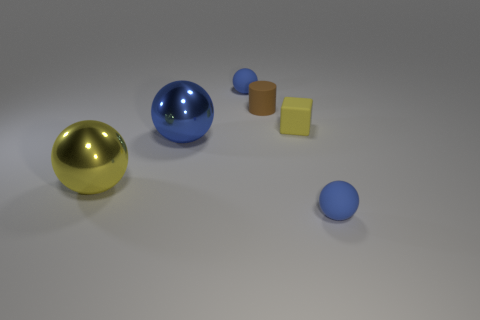Subtract all large yellow spheres. How many spheres are left? 3 Subtract all green cylinders. How many blue balls are left? 3 Subtract all yellow balls. How many balls are left? 3 Subtract 1 spheres. How many spheres are left? 3 Subtract all brown balls. Subtract all blue cubes. How many balls are left? 4 Add 3 tiny blue balls. How many objects exist? 9 Subtract all spheres. How many objects are left? 2 Subtract all large purple metal things. Subtract all small matte balls. How many objects are left? 4 Add 2 cubes. How many cubes are left? 3 Add 6 blue objects. How many blue objects exist? 9 